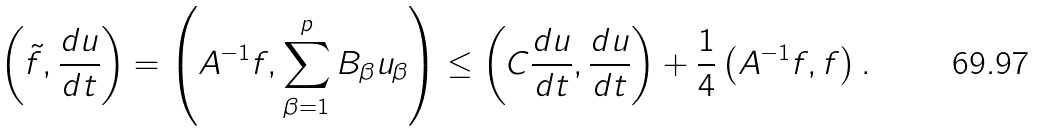Convert formula to latex. <formula><loc_0><loc_0><loc_500><loc_500>\left ( \tilde { f } , \frac { d u } { d t } \right ) = \left ( A ^ { - 1 } f , \sum _ { \beta = 1 } ^ { p } B _ { \beta } u _ { \beta } \right ) \leq \left ( C \frac { d u } { d t } , \frac { d u } { d t } \right ) + \frac { 1 } { 4 } \left ( A ^ { - 1 } f , f \right ) .</formula> 